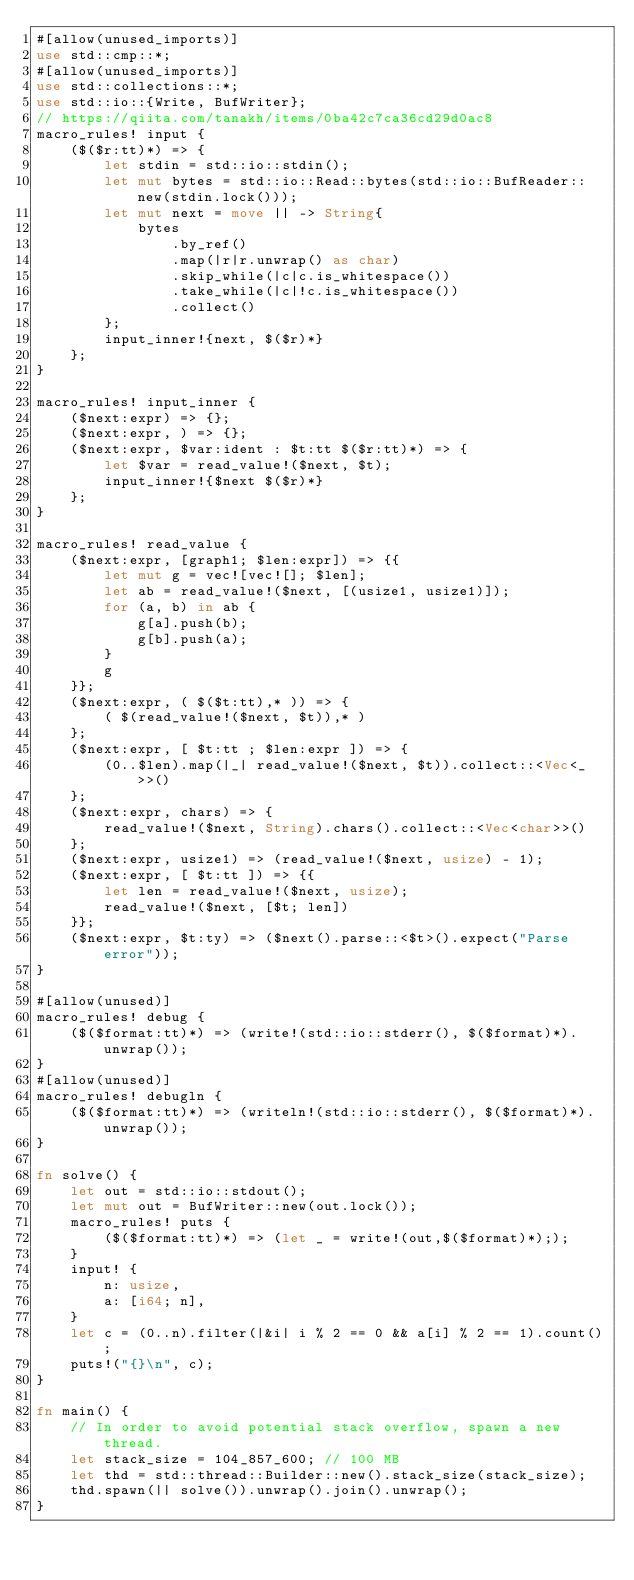<code> <loc_0><loc_0><loc_500><loc_500><_Rust_>#[allow(unused_imports)]
use std::cmp::*;
#[allow(unused_imports)]
use std::collections::*;
use std::io::{Write, BufWriter};
// https://qiita.com/tanakh/items/0ba42c7ca36cd29d0ac8
macro_rules! input {
    ($($r:tt)*) => {
        let stdin = std::io::stdin();
        let mut bytes = std::io::Read::bytes(std::io::BufReader::new(stdin.lock()));
        let mut next = move || -> String{
            bytes
                .by_ref()
                .map(|r|r.unwrap() as char)
                .skip_while(|c|c.is_whitespace())
                .take_while(|c|!c.is_whitespace())
                .collect()
        };
        input_inner!{next, $($r)*}
    };
}

macro_rules! input_inner {
    ($next:expr) => {};
    ($next:expr, ) => {};
    ($next:expr, $var:ident : $t:tt $($r:tt)*) => {
        let $var = read_value!($next, $t);
        input_inner!{$next $($r)*}
    };
}

macro_rules! read_value {
    ($next:expr, [graph1; $len:expr]) => {{
        let mut g = vec![vec![]; $len];
        let ab = read_value!($next, [(usize1, usize1)]);
        for (a, b) in ab {
            g[a].push(b);
            g[b].push(a);
        }
        g
    }};
    ($next:expr, ( $($t:tt),* )) => {
        ( $(read_value!($next, $t)),* )
    };
    ($next:expr, [ $t:tt ; $len:expr ]) => {
        (0..$len).map(|_| read_value!($next, $t)).collect::<Vec<_>>()
    };
    ($next:expr, chars) => {
        read_value!($next, String).chars().collect::<Vec<char>>()
    };
    ($next:expr, usize1) => (read_value!($next, usize) - 1);
    ($next:expr, [ $t:tt ]) => {{
        let len = read_value!($next, usize);
        read_value!($next, [$t; len])
    }};
    ($next:expr, $t:ty) => ($next().parse::<$t>().expect("Parse error"));
}

#[allow(unused)]
macro_rules! debug {
    ($($format:tt)*) => (write!(std::io::stderr(), $($format)*).unwrap());
}
#[allow(unused)]
macro_rules! debugln {
    ($($format:tt)*) => (writeln!(std::io::stderr(), $($format)*).unwrap());
}

fn solve() {
    let out = std::io::stdout();
    let mut out = BufWriter::new(out.lock());
    macro_rules! puts {
        ($($format:tt)*) => (let _ = write!(out,$($format)*););
    }
    input! {
        n: usize,
        a: [i64; n],
    }
    let c = (0..n).filter(|&i| i % 2 == 0 && a[i] % 2 == 1).count();
    puts!("{}\n", c);
}

fn main() {
    // In order to avoid potential stack overflow, spawn a new thread.
    let stack_size = 104_857_600; // 100 MB
    let thd = std::thread::Builder::new().stack_size(stack_size);
    thd.spawn(|| solve()).unwrap().join().unwrap();
}
</code> 